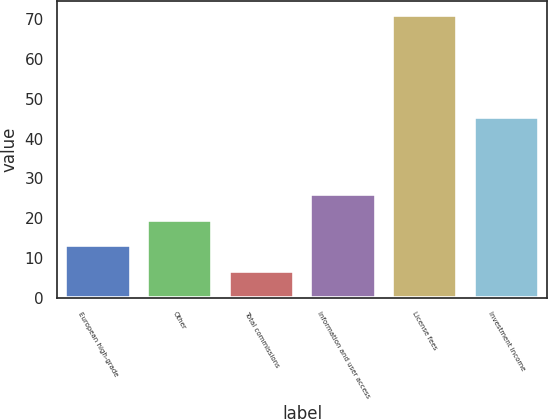Convert chart to OTSL. <chart><loc_0><loc_0><loc_500><loc_500><bar_chart><fcel>European high-grade<fcel>Other<fcel>Total commissions<fcel>Information and user access<fcel>License fees<fcel>Investment income<nl><fcel>13.13<fcel>19.56<fcel>6.7<fcel>25.99<fcel>71<fcel>45.4<nl></chart> 